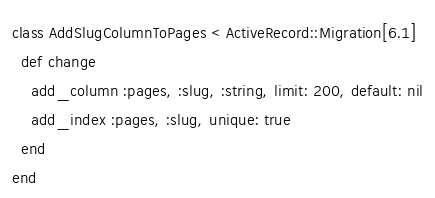Convert code to text. <code><loc_0><loc_0><loc_500><loc_500><_Ruby_>class AddSlugColumnToPages < ActiveRecord::Migration[6.1]
  def change
    add_column :pages, :slug, :string, limit: 200, default: nil
    add_index :pages, :slug, unique: true
  end
end
</code> 